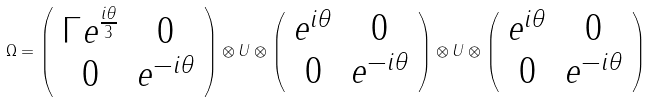<formula> <loc_0><loc_0><loc_500><loc_500>\Omega = \left ( \begin{array} { c c } \Gamma e ^ { \frac { i \theta } { 3 } } & 0 \\ 0 & e ^ { - i \theta } \end{array} \right ) \otimes U \otimes \left ( \begin{array} { c c } e ^ { i \theta } & 0 \\ 0 & e ^ { - i \theta } \end{array} \right ) \otimes U \otimes \left ( \begin{array} { c c } e ^ { i \theta } & 0 \\ 0 & e ^ { - i \theta } \end{array} \right )</formula> 